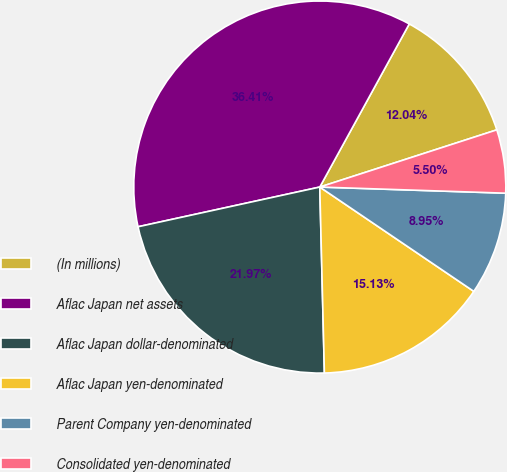Convert chart. <chart><loc_0><loc_0><loc_500><loc_500><pie_chart><fcel>(In millions)<fcel>Aflac Japan net assets<fcel>Aflac Japan dollar-denominated<fcel>Aflac Japan yen-denominated<fcel>Parent Company yen-denominated<fcel>Consolidated yen-denominated<nl><fcel>12.04%<fcel>36.41%<fcel>21.97%<fcel>15.13%<fcel>8.95%<fcel>5.5%<nl></chart> 